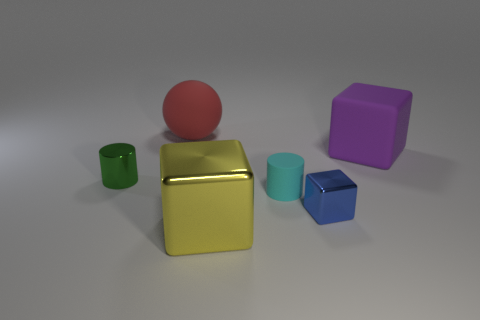What is the cylinder that is right of the big red matte object on the right side of the small thing behind the tiny matte cylinder made of?
Give a very brief answer. Rubber. Do the blue thing and the ball have the same size?
Your response must be concise. No. Do the large metallic block and the shiny thing that is left of the large red matte ball have the same color?
Your answer should be compact. No. What is the shape of the small cyan thing that is made of the same material as the purple cube?
Give a very brief answer. Cylinder. There is a small thing that is on the left side of the yellow shiny thing; is its shape the same as the cyan rubber thing?
Make the answer very short. Yes. There is a block behind the small shiny thing that is on the right side of the tiny green metal cylinder; what is its size?
Your response must be concise. Large. There is a block that is the same material as the small cyan object; what color is it?
Keep it short and to the point. Purple. What number of blue things have the same size as the green metal cylinder?
Offer a very short reply. 1. How many gray objects are either small blocks or big matte spheres?
Keep it short and to the point. 0. How many objects are either blue metal blocks or cubes that are in front of the small cyan matte cylinder?
Offer a very short reply. 2. 